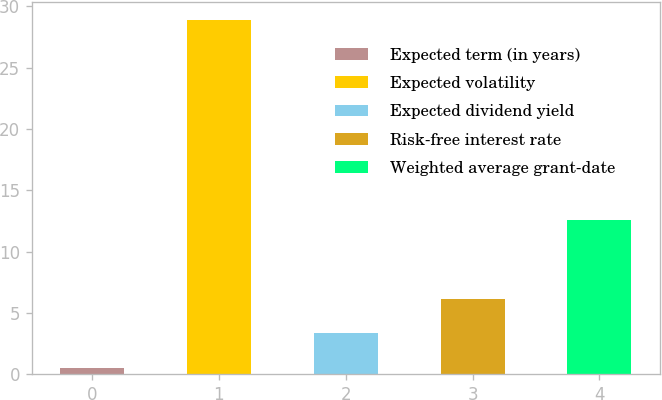Convert chart to OTSL. <chart><loc_0><loc_0><loc_500><loc_500><bar_chart><fcel>Expected term (in years)<fcel>Expected volatility<fcel>Expected dividend yield<fcel>Risk-free interest rate<fcel>Weighted average grant-date<nl><fcel>0.5<fcel>28.88<fcel>3.34<fcel>6.18<fcel>12.58<nl></chart> 